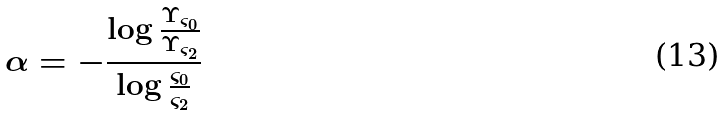<formula> <loc_0><loc_0><loc_500><loc_500>\alpha = - \frac { \log \frac { \Upsilon _ { \varsigma _ { 0 } } } { \Upsilon _ { \varsigma _ { 2 } } } } { \log \frac { \varsigma _ { 0 } } { \varsigma _ { 2 } } }</formula> 